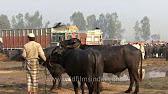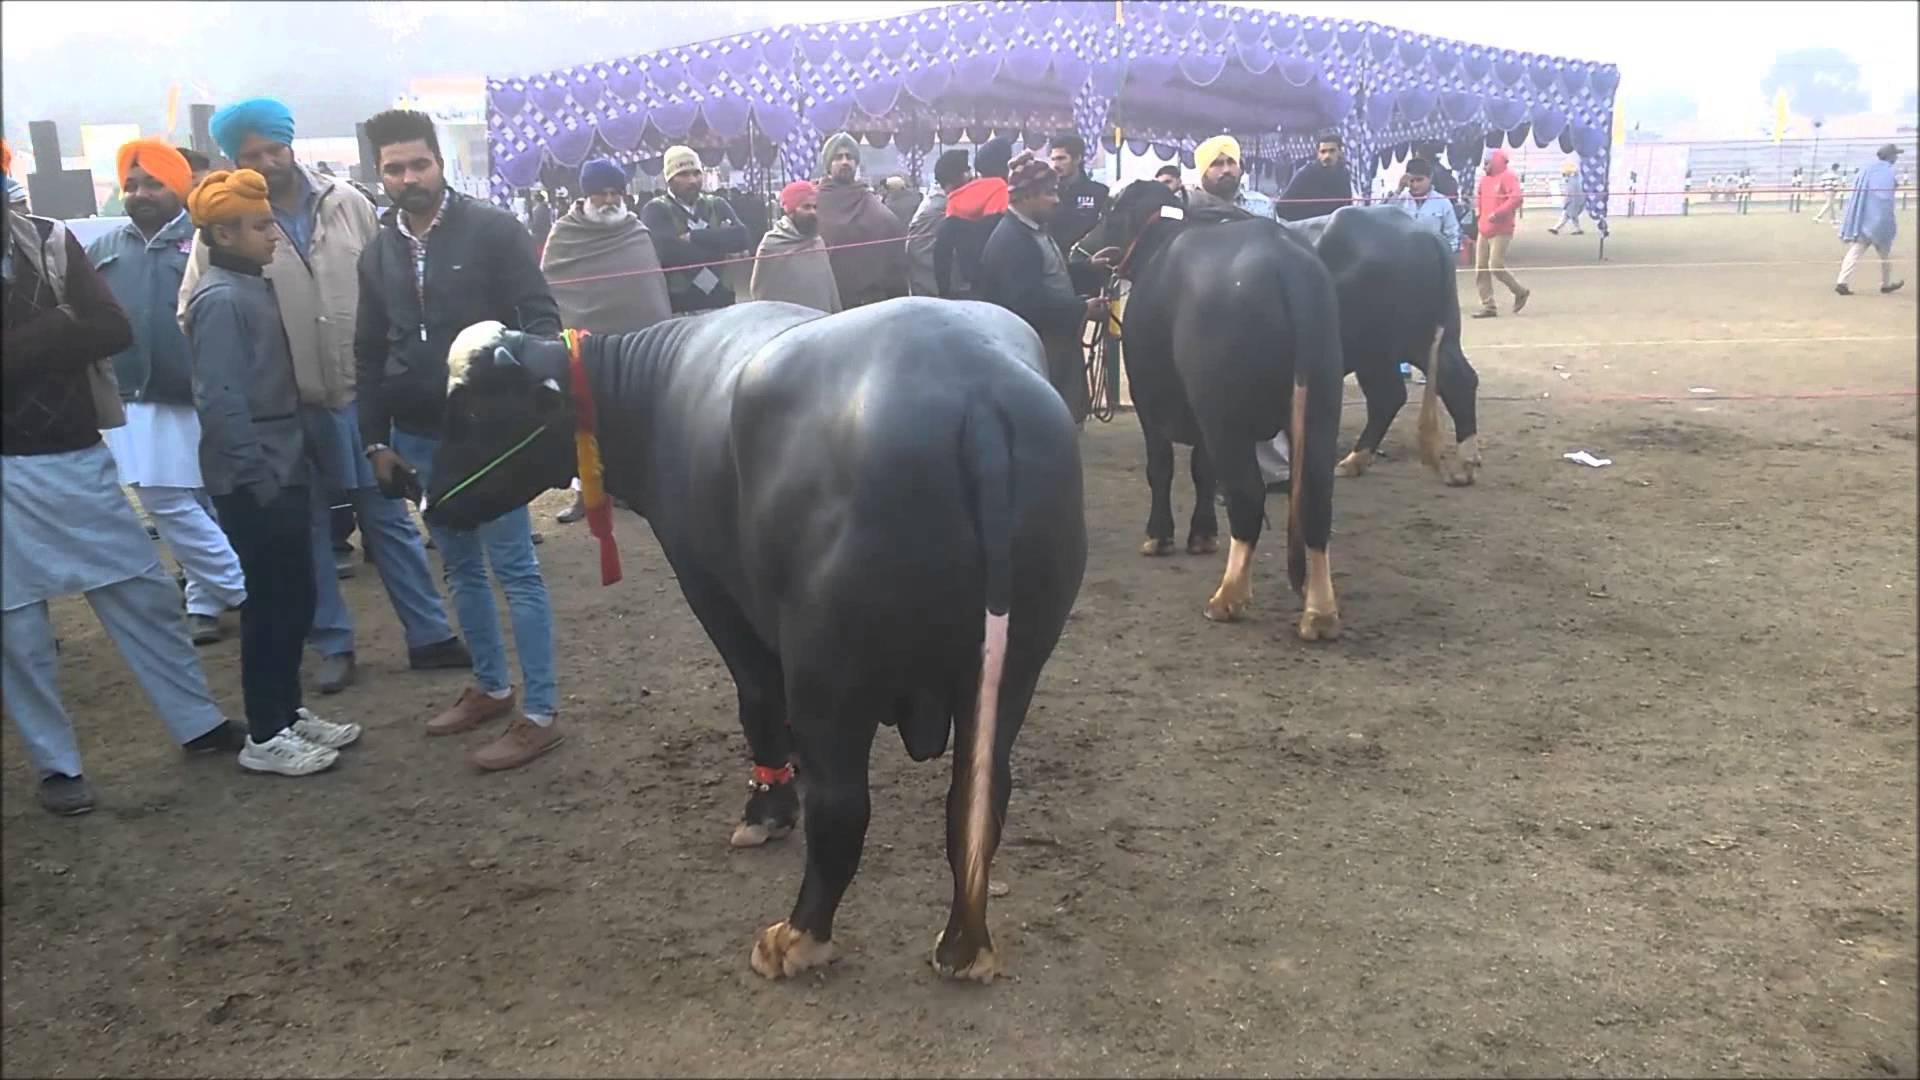The first image is the image on the left, the second image is the image on the right. Examine the images to the left and right. Is the description "One image shows cattle standing facing forward on dirt ground, with columns holding up a roof in the background but no people present." accurate? Answer yes or no. No. 